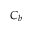Convert formula to latex. <formula><loc_0><loc_0><loc_500><loc_500>C _ { b }</formula> 